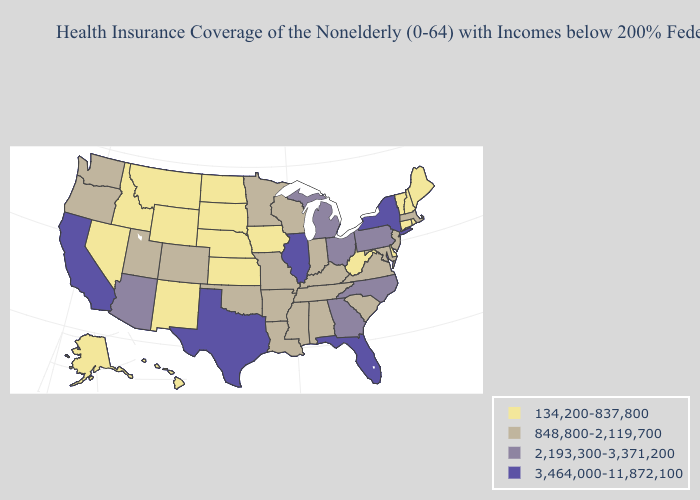Does New Mexico have the same value as South Carolina?
Short answer required. No. Which states have the lowest value in the West?
Give a very brief answer. Alaska, Hawaii, Idaho, Montana, Nevada, New Mexico, Wyoming. Name the states that have a value in the range 2,193,300-3,371,200?
Answer briefly. Arizona, Georgia, Michigan, North Carolina, Ohio, Pennsylvania. What is the lowest value in the Northeast?
Be succinct. 134,200-837,800. Which states have the lowest value in the MidWest?
Quick response, please. Iowa, Kansas, Nebraska, North Dakota, South Dakota. Name the states that have a value in the range 2,193,300-3,371,200?
Quick response, please. Arizona, Georgia, Michigan, North Carolina, Ohio, Pennsylvania. Among the states that border Illinois , does Wisconsin have the highest value?
Concise answer only. Yes. Among the states that border Oregon , does Idaho have the lowest value?
Give a very brief answer. Yes. How many symbols are there in the legend?
Answer briefly. 4. Does Idaho have a lower value than Massachusetts?
Be succinct. Yes. What is the value of Pennsylvania?
Answer briefly. 2,193,300-3,371,200. Name the states that have a value in the range 2,193,300-3,371,200?
Write a very short answer. Arizona, Georgia, Michigan, North Carolina, Ohio, Pennsylvania. Does Wyoming have the lowest value in the USA?
Answer briefly. Yes. Which states have the highest value in the USA?
Answer briefly. California, Florida, Illinois, New York, Texas. What is the value of South Dakota?
Answer briefly. 134,200-837,800. 